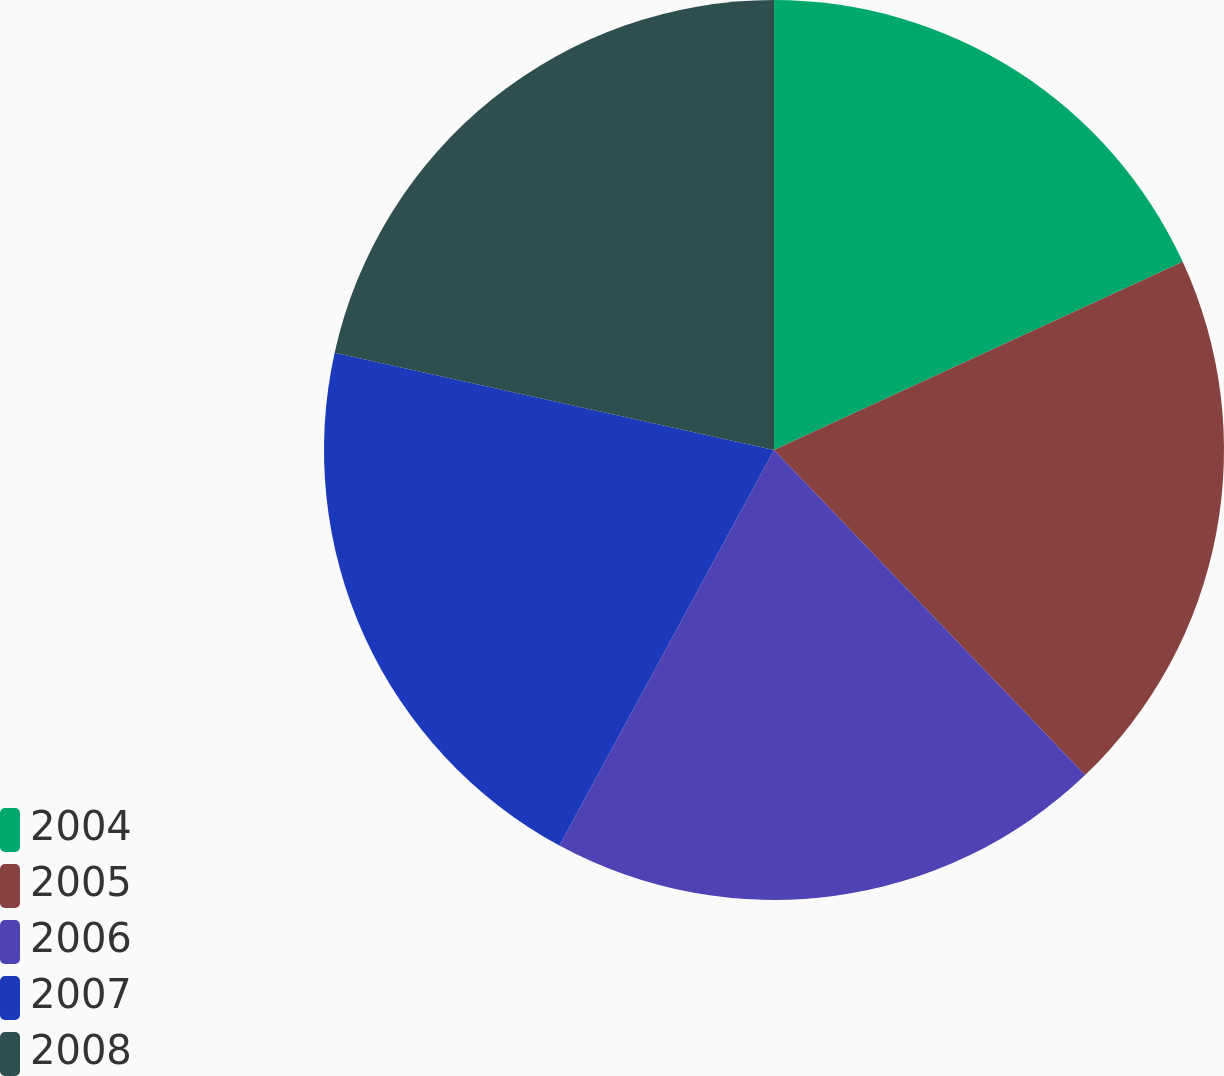Convert chart to OTSL. <chart><loc_0><loc_0><loc_500><loc_500><pie_chart><fcel>2004<fcel>2005<fcel>2006<fcel>2007<fcel>2008<nl><fcel>18.13%<fcel>19.72%<fcel>20.06%<fcel>20.56%<fcel>21.53%<nl></chart> 